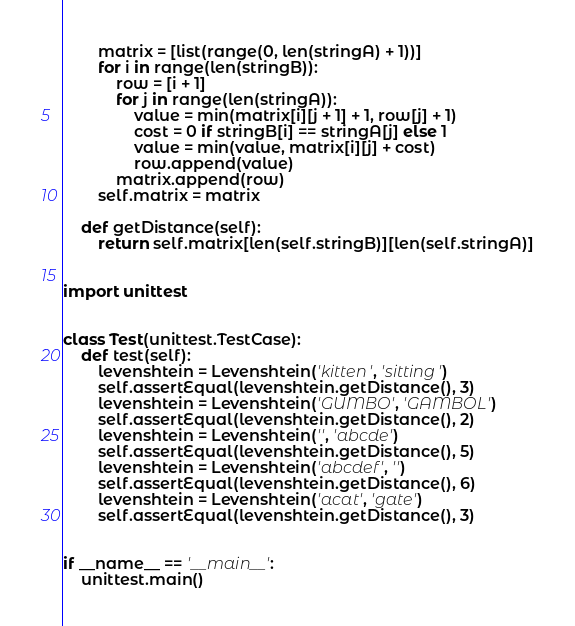Convert code to text. <code><loc_0><loc_0><loc_500><loc_500><_Python_>        matrix = [list(range(0, len(stringA) + 1))]
        for i in range(len(stringB)):
            row = [i + 1]
            for j in range(len(stringA)):
                value = min(matrix[i][j + 1] + 1, row[j] + 1)
                cost = 0 if stringB[i] == stringA[j] else 1
                value = min(value, matrix[i][j] + cost)
                row.append(value)
            matrix.append(row)
        self.matrix = matrix

    def getDistance(self):
        return self.matrix[len(self.stringB)][len(self.stringA)]


import unittest


class Test(unittest.TestCase):
    def test(self):
        levenshtein = Levenshtein('kitten', 'sitting')
        self.assertEqual(levenshtein.getDistance(), 3)
        levenshtein = Levenshtein('GUMBO', 'GAMBOL')
        self.assertEqual(levenshtein.getDistance(), 2)
        levenshtein = Levenshtein('', 'abcde')
        self.assertEqual(levenshtein.getDistance(), 5)
        levenshtein = Levenshtein('abcdef', '')
        self.assertEqual(levenshtein.getDistance(), 6)
        levenshtein = Levenshtein('acat', 'gate')
        self.assertEqual(levenshtein.getDistance(), 3)


if __name__ == '__main__':
    unittest.main()
</code> 